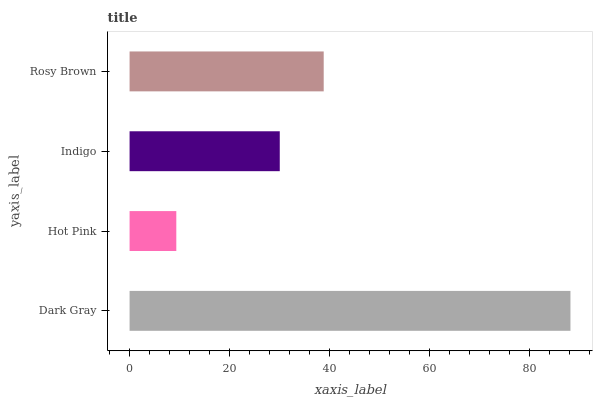Is Hot Pink the minimum?
Answer yes or no. Yes. Is Dark Gray the maximum?
Answer yes or no. Yes. Is Indigo the minimum?
Answer yes or no. No. Is Indigo the maximum?
Answer yes or no. No. Is Indigo greater than Hot Pink?
Answer yes or no. Yes. Is Hot Pink less than Indigo?
Answer yes or no. Yes. Is Hot Pink greater than Indigo?
Answer yes or no. No. Is Indigo less than Hot Pink?
Answer yes or no. No. Is Rosy Brown the high median?
Answer yes or no. Yes. Is Indigo the low median?
Answer yes or no. Yes. Is Dark Gray the high median?
Answer yes or no. No. Is Hot Pink the low median?
Answer yes or no. No. 